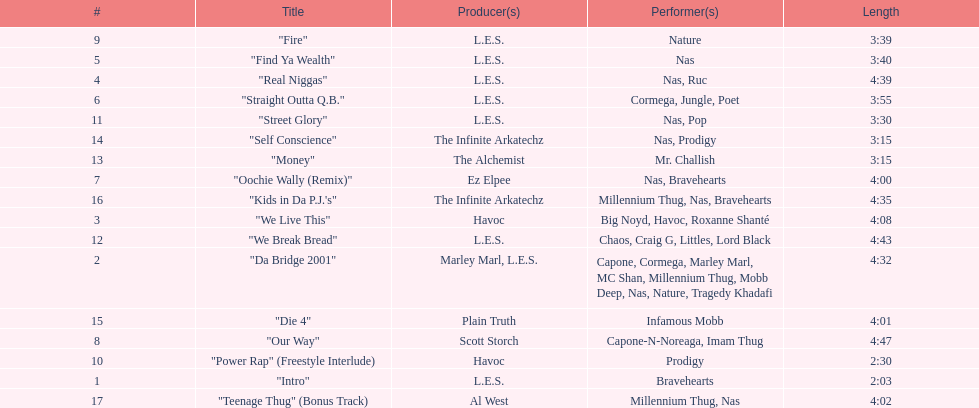What is the first song on the album produced by havoc? "We Live This". 